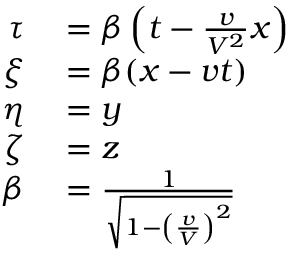<formula> <loc_0><loc_0><loc_500><loc_500>\begin{array} { r l } { \tau } & = \beta \left ( t - { \frac { v } { V ^ { 2 } } } x \right ) } \\ { \xi } & = \beta ( x - v t ) } \\ { \eta } & = y } \\ { \zeta } & = z } \\ { \beta } & = { \frac { 1 } { \sqrt { 1 - \left ( { \frac { v } { V } } \right ) ^ { 2 } } } } } \end{array}</formula> 